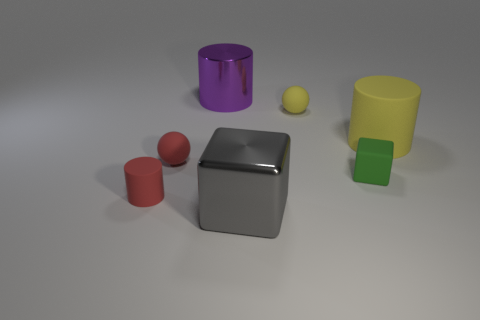Subtract all metallic cylinders. How many cylinders are left? 2 Add 3 tiny green cubes. How many objects exist? 10 Subtract all blocks. How many objects are left? 5 Add 5 red matte cylinders. How many red matte cylinders exist? 6 Subtract 1 yellow cylinders. How many objects are left? 6 Subtract all green cylinders. Subtract all cyan blocks. How many cylinders are left? 3 Subtract all big green matte spheres. Subtract all big purple cylinders. How many objects are left? 6 Add 2 green cubes. How many green cubes are left? 3 